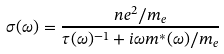Convert formula to latex. <formula><loc_0><loc_0><loc_500><loc_500>\sigma ( \omega ) = \frac { n e ^ { 2 } / m _ { e } } { \tau ( \omega ) ^ { - 1 } + i \omega m ^ { * } ( \omega ) / m _ { e } }</formula> 